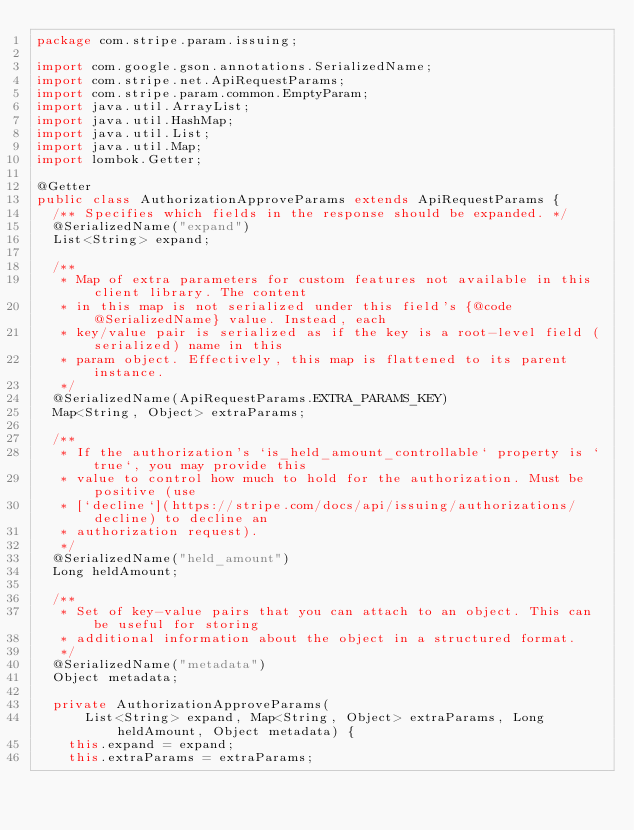Convert code to text. <code><loc_0><loc_0><loc_500><loc_500><_Java_>package com.stripe.param.issuing;

import com.google.gson.annotations.SerializedName;
import com.stripe.net.ApiRequestParams;
import com.stripe.param.common.EmptyParam;
import java.util.ArrayList;
import java.util.HashMap;
import java.util.List;
import java.util.Map;
import lombok.Getter;

@Getter
public class AuthorizationApproveParams extends ApiRequestParams {
  /** Specifies which fields in the response should be expanded. */
  @SerializedName("expand")
  List<String> expand;

  /**
   * Map of extra parameters for custom features not available in this client library. The content
   * in this map is not serialized under this field's {@code @SerializedName} value. Instead, each
   * key/value pair is serialized as if the key is a root-level field (serialized) name in this
   * param object. Effectively, this map is flattened to its parent instance.
   */
  @SerializedName(ApiRequestParams.EXTRA_PARAMS_KEY)
  Map<String, Object> extraParams;

  /**
   * If the authorization's `is_held_amount_controllable` property is `true`, you may provide this
   * value to control how much to hold for the authorization. Must be positive (use
   * [`decline`](https://stripe.com/docs/api/issuing/authorizations/decline) to decline an
   * authorization request).
   */
  @SerializedName("held_amount")
  Long heldAmount;

  /**
   * Set of key-value pairs that you can attach to an object. This can be useful for storing
   * additional information about the object in a structured format.
   */
  @SerializedName("metadata")
  Object metadata;

  private AuthorizationApproveParams(
      List<String> expand, Map<String, Object> extraParams, Long heldAmount, Object metadata) {
    this.expand = expand;
    this.extraParams = extraParams;</code> 